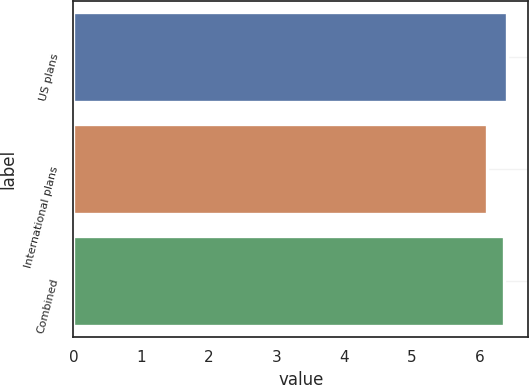<chart> <loc_0><loc_0><loc_500><loc_500><bar_chart><fcel>US plans<fcel>International plans<fcel>Combined<nl><fcel>6.4<fcel>6.11<fcel>6.37<nl></chart> 